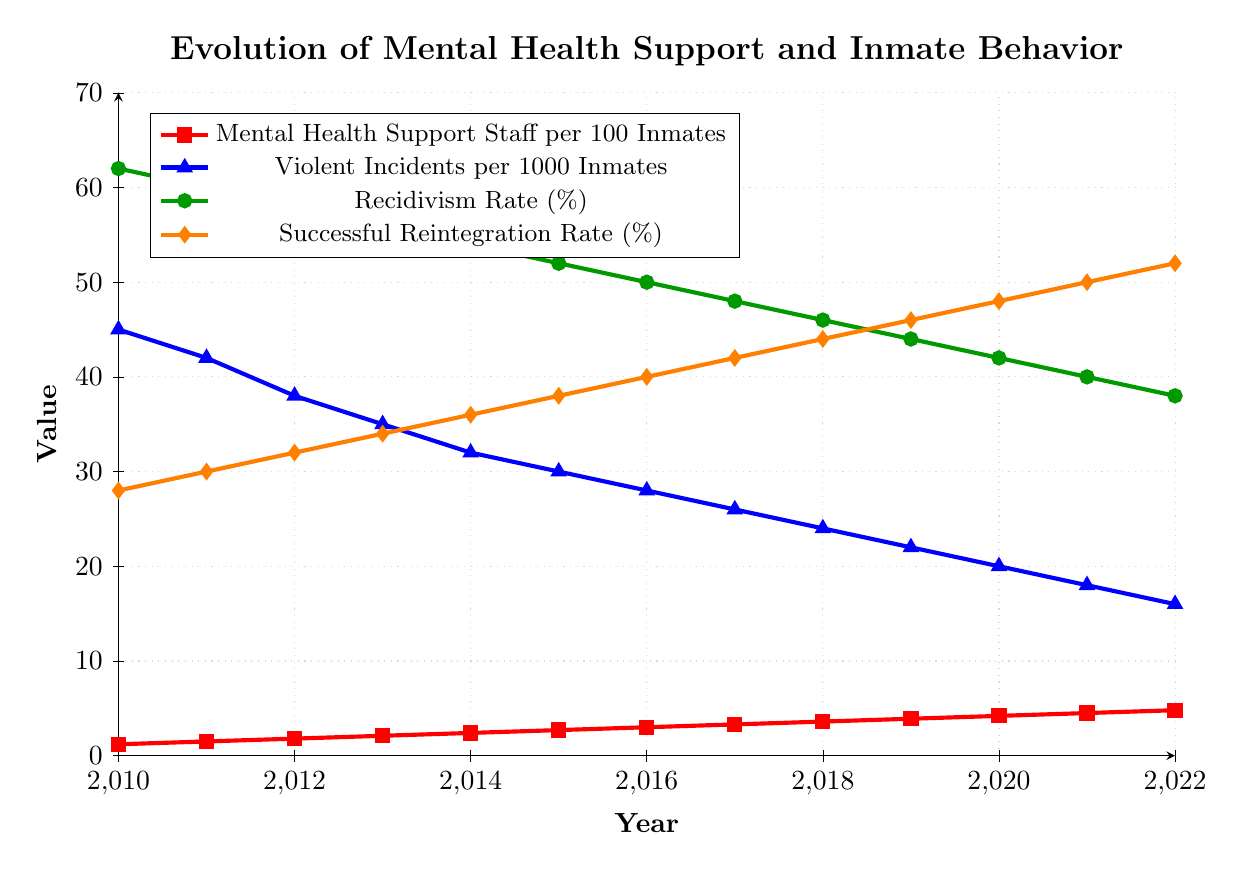What can be observed about the trend of Mental Health Support Staff availability from 2010 to 2022? The plot shows a line for Mental Health Support Staff per 100 Inmates in red, gradually rising from 1.2 to 4.8 over the years, indicating an increase in availability each year.
Answer: It has been increasing How do Violent Incidents per 1000 Inmates change in relation to the increase in Mental Health Support Staff? The blue line representing Violent Incidents per 1000 Inmates shows a downward trend from 45 in 2010 to 16 in 2022 as Mental Health Support Staff per 100 Inmates increased, suggesting an inverse relationship.
Answer: They decrease Which year shows the highest Successful Reintegration Rate and by how much did it increase compared to 2010? The orange line indicates the Successful Reintegration Rate. In 2022, it is the highest at 52%. From 2010 to 2022, it increased from 28% to 52%, so the increase is 52% - 28% = 24%.
Answer: 2022, by 24% What can be inferred about the Recidivism Rate trend over the years and its potential correlation with Mental Health Support Staff? The green line for Recidivism Rate shows a gradual decline from 62% in 2010 to 38% in 2022, while Mental Health Support Staff availability increased, indicating a potential inverse correlation between them.
Answer: Recidivism Rate decreases, potentially inversely correlated with Mental Health Support Staff By how much did Violent Incidents per 1000 Inmates decrease between 2014 and 2019? The blue line shows Violent Incidents per 1000 Inmates at 32 in 2014 and 22 in 2019. The decrease is 32 - 22 = 10.
Answer: By 10 Compare the trend of Violent Incidents per 1000 Inmates to Recidivism Rate from 2013 to 2016. From 2013 to 2016, the blue line for Violent Incidents per 1000 Inmates goes from 35 to 28 (decreases) and the green line for Recidivism Rate drops from 56% to 50%. Both indicators are decreasing during this period, showing a similar declining trend.
Answer: Both decrease What visual attributes indicate the year with the lowest amount of Mental Health Support Staff per 100 Inmates? The red line starts with the lowest point on the y-axis in 2010, indicating that 2010 is the year with the lowest amount at 1.2.
Answer: 2010 How does the Successful Reintegration Rate in 2020 compare to the Recidivism Rate in 2015? The orange line for Successful Reintegration Rate in 2020 is at 48%, and the green line for Recidivism Rate in 2015 is at 52%. The Successful Reintegration Rate in 2020 is slightly lower than the Recidivism Rate in 2015.
Answer: It is 4% lower What is the overall trend of the Recidivism Rate, and how does it differ from the trend of the Successful Reintegration Rate? The green line for Recidivism Rate consistently declines over time from 62% in 2010 to 38% in 2022. The orange line for Successful Reintegration Rate consistently rises from 28% in 2010 to 52% in 2022, showing opposite trends.
Answer: Recidivism Rate decreases, Successful Reintegration Rate increases 